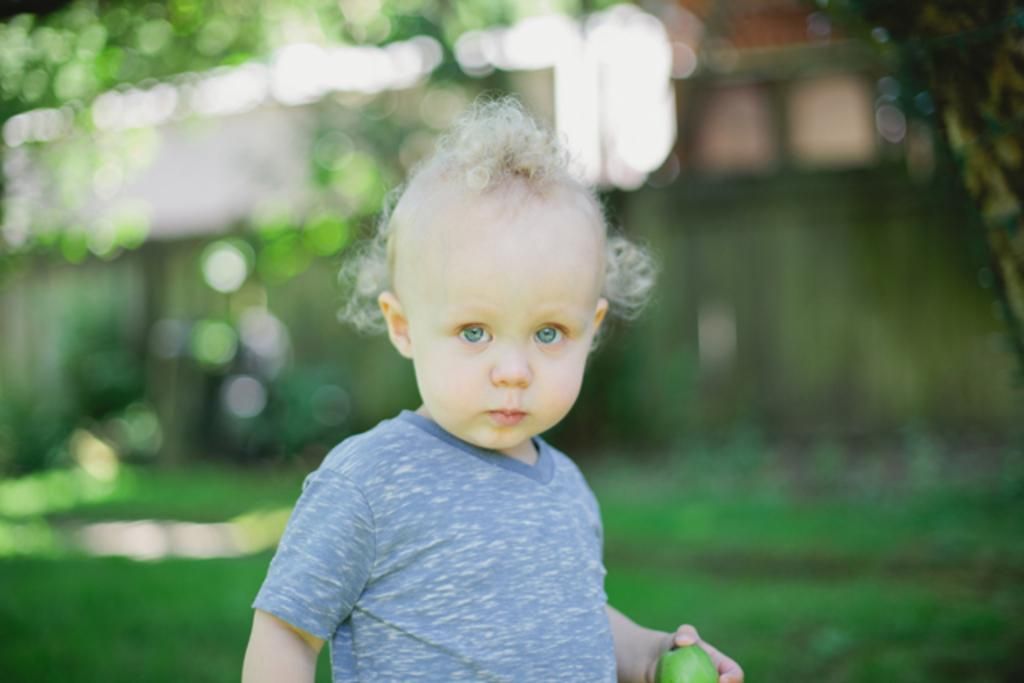What is the main subject of the image? The main subject of the image is a kid. What is the kid holding in the image? The kid is holding a fruit in the image. Where is the fruit located in relation to the kid? The fruit is located at the bottom of the image. What type of record can be seen spinning on the table in the image? There is no record present in the image; it features a kid holding a fruit. Is there a volcano erupting in the background of the image? There is no volcano present in the image; it features a kid holding a fruit. 